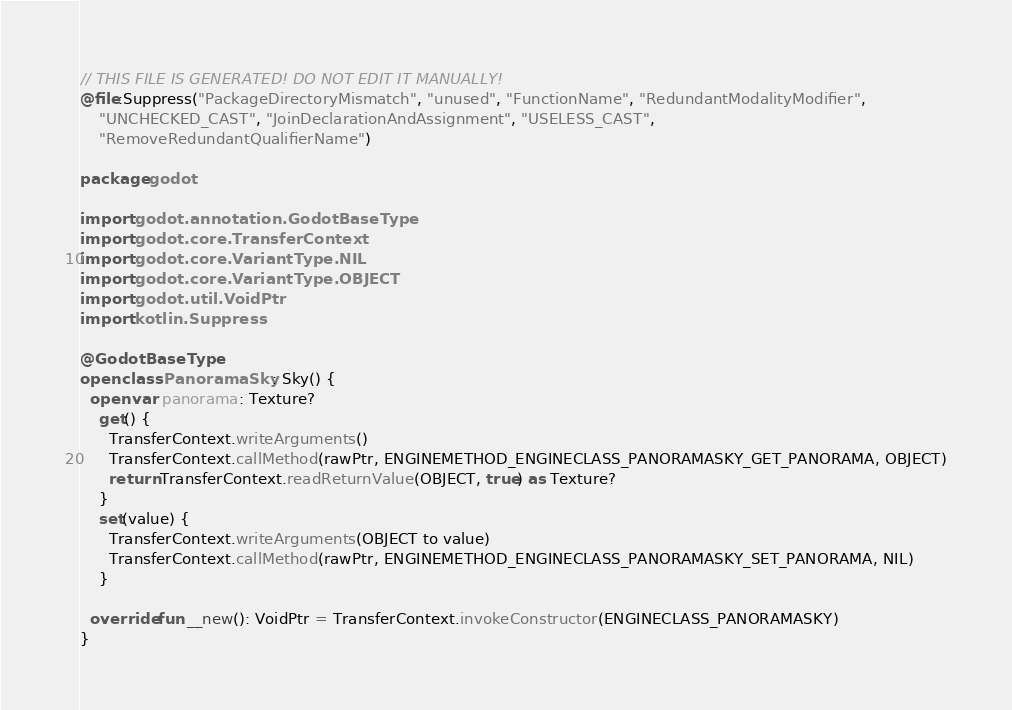Convert code to text. <code><loc_0><loc_0><loc_500><loc_500><_Kotlin_>// THIS FILE IS GENERATED! DO NOT EDIT IT MANUALLY!
@file:Suppress("PackageDirectoryMismatch", "unused", "FunctionName", "RedundantModalityModifier",
    "UNCHECKED_CAST", "JoinDeclarationAndAssignment", "USELESS_CAST",
    "RemoveRedundantQualifierName")

package godot

import godot.annotation.GodotBaseType
import godot.core.TransferContext
import godot.core.VariantType.NIL
import godot.core.VariantType.OBJECT
import godot.util.VoidPtr
import kotlin.Suppress

@GodotBaseType
open class PanoramaSky : Sky() {
  open var panorama: Texture?
    get() {
      TransferContext.writeArguments()
      TransferContext.callMethod(rawPtr, ENGINEMETHOD_ENGINECLASS_PANORAMASKY_GET_PANORAMA, OBJECT)
      return TransferContext.readReturnValue(OBJECT, true) as Texture?
    }
    set(value) {
      TransferContext.writeArguments(OBJECT to value)
      TransferContext.callMethod(rawPtr, ENGINEMETHOD_ENGINECLASS_PANORAMASKY_SET_PANORAMA, NIL)
    }

  override fun __new(): VoidPtr = TransferContext.invokeConstructor(ENGINECLASS_PANORAMASKY)
}
</code> 